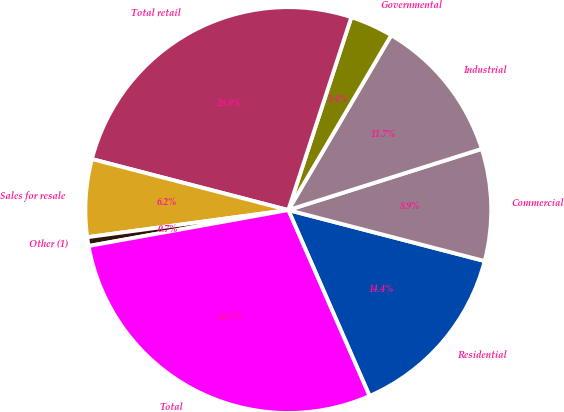Convert chart. <chart><loc_0><loc_0><loc_500><loc_500><pie_chart><fcel>Residential<fcel>Commercial<fcel>Industrial<fcel>Governmental<fcel>Total retail<fcel>Sales for resale<fcel>Other (1)<fcel>Total<nl><fcel>14.4%<fcel>8.92%<fcel>11.66%<fcel>3.44%<fcel>25.99%<fcel>6.18%<fcel>0.7%<fcel>28.73%<nl></chart> 